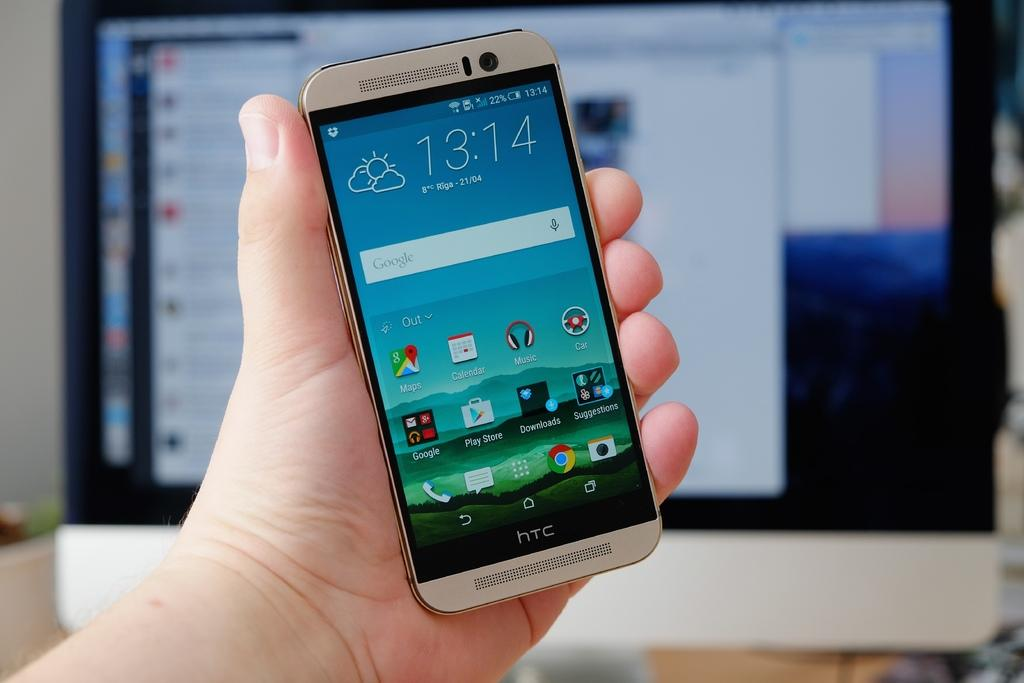<image>
Relay a brief, clear account of the picture shown. an HTC cell phone with a display reading 13:!4 held in a hand 